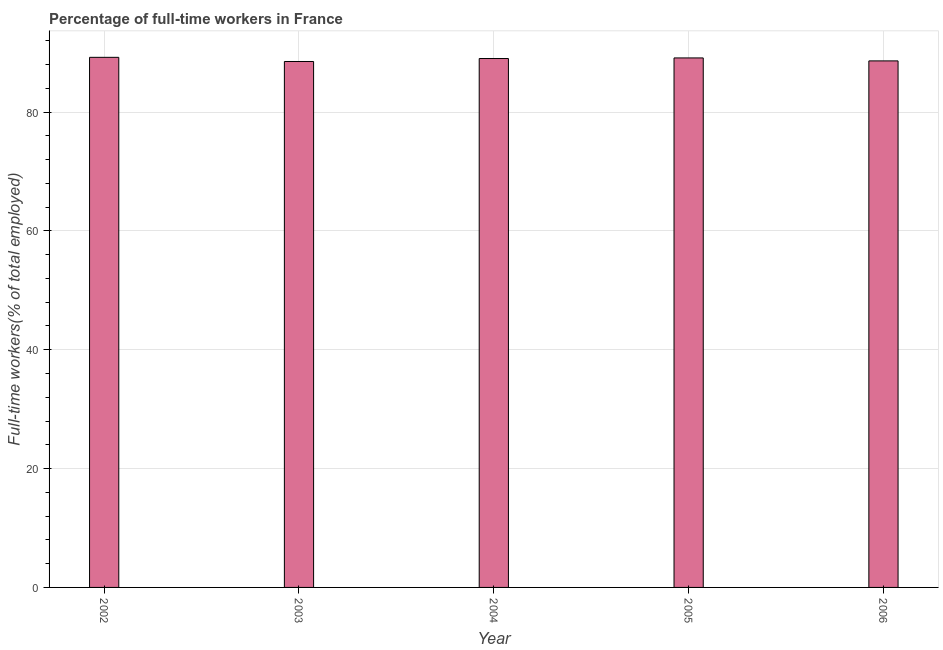Does the graph contain any zero values?
Make the answer very short. No. What is the title of the graph?
Your answer should be very brief. Percentage of full-time workers in France. What is the label or title of the X-axis?
Your response must be concise. Year. What is the label or title of the Y-axis?
Make the answer very short. Full-time workers(% of total employed). What is the percentage of full-time workers in 2004?
Your response must be concise. 89. Across all years, what is the maximum percentage of full-time workers?
Give a very brief answer. 89.2. Across all years, what is the minimum percentage of full-time workers?
Your answer should be compact. 88.5. In which year was the percentage of full-time workers minimum?
Your answer should be compact. 2003. What is the sum of the percentage of full-time workers?
Provide a succinct answer. 444.4. What is the difference between the percentage of full-time workers in 2002 and 2005?
Give a very brief answer. 0.1. What is the average percentage of full-time workers per year?
Offer a terse response. 88.88. What is the median percentage of full-time workers?
Give a very brief answer. 89. In how many years, is the percentage of full-time workers greater than 56 %?
Offer a very short reply. 5. Do a majority of the years between 2003 and 2004 (inclusive) have percentage of full-time workers greater than 40 %?
Provide a succinct answer. Yes. What is the difference between the highest and the second highest percentage of full-time workers?
Provide a succinct answer. 0.1. Is the sum of the percentage of full-time workers in 2003 and 2004 greater than the maximum percentage of full-time workers across all years?
Provide a short and direct response. Yes. How many bars are there?
Your answer should be compact. 5. How many years are there in the graph?
Your answer should be very brief. 5. What is the Full-time workers(% of total employed) in 2002?
Your response must be concise. 89.2. What is the Full-time workers(% of total employed) in 2003?
Offer a very short reply. 88.5. What is the Full-time workers(% of total employed) of 2004?
Offer a terse response. 89. What is the Full-time workers(% of total employed) of 2005?
Offer a terse response. 89.1. What is the Full-time workers(% of total employed) of 2006?
Provide a short and direct response. 88.6. What is the difference between the Full-time workers(% of total employed) in 2002 and 2004?
Offer a terse response. 0.2. What is the difference between the Full-time workers(% of total employed) in 2002 and 2005?
Your answer should be compact. 0.1. What is the difference between the Full-time workers(% of total employed) in 2002 and 2006?
Keep it short and to the point. 0.6. What is the difference between the Full-time workers(% of total employed) in 2003 and 2005?
Make the answer very short. -0.6. What is the difference between the Full-time workers(% of total employed) in 2003 and 2006?
Your response must be concise. -0.1. What is the difference between the Full-time workers(% of total employed) in 2005 and 2006?
Keep it short and to the point. 0.5. What is the ratio of the Full-time workers(% of total employed) in 2002 to that in 2003?
Make the answer very short. 1.01. What is the ratio of the Full-time workers(% of total employed) in 2002 to that in 2005?
Keep it short and to the point. 1. What is the ratio of the Full-time workers(% of total employed) in 2003 to that in 2004?
Ensure brevity in your answer.  0.99. 